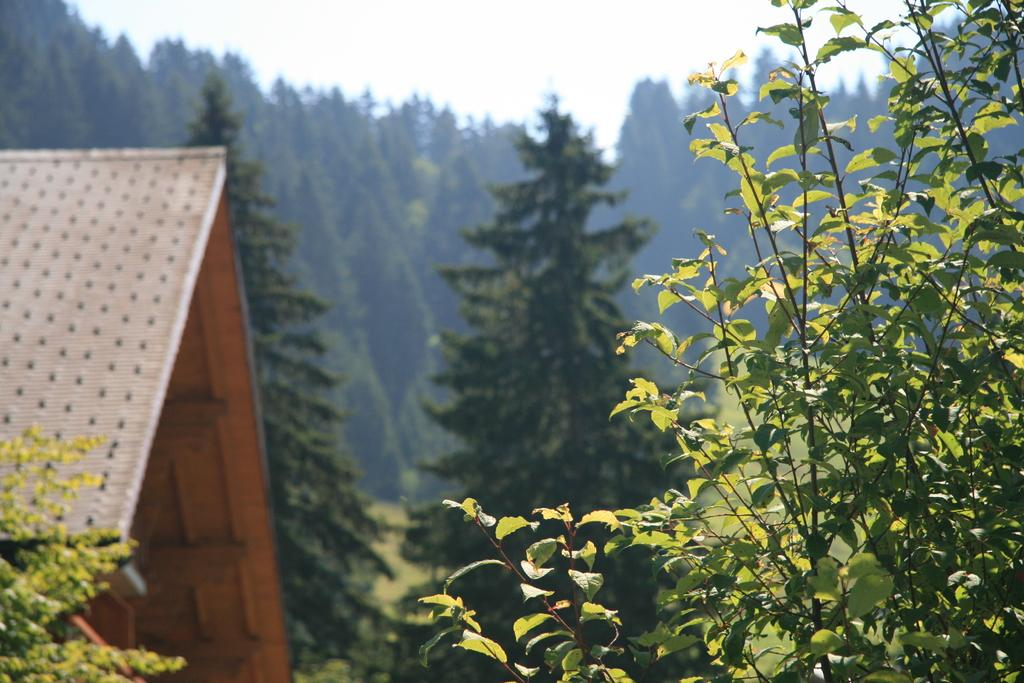What can be seen at the top of the image? The sky is visible in the image. What type of structure is present in the image? There is a house in the image. What type of vegetation is present in the image? There are trees and plants in the image. What is the weight of the twist in the image? There is no twist present in the image, so it is not possible to determine its weight. 